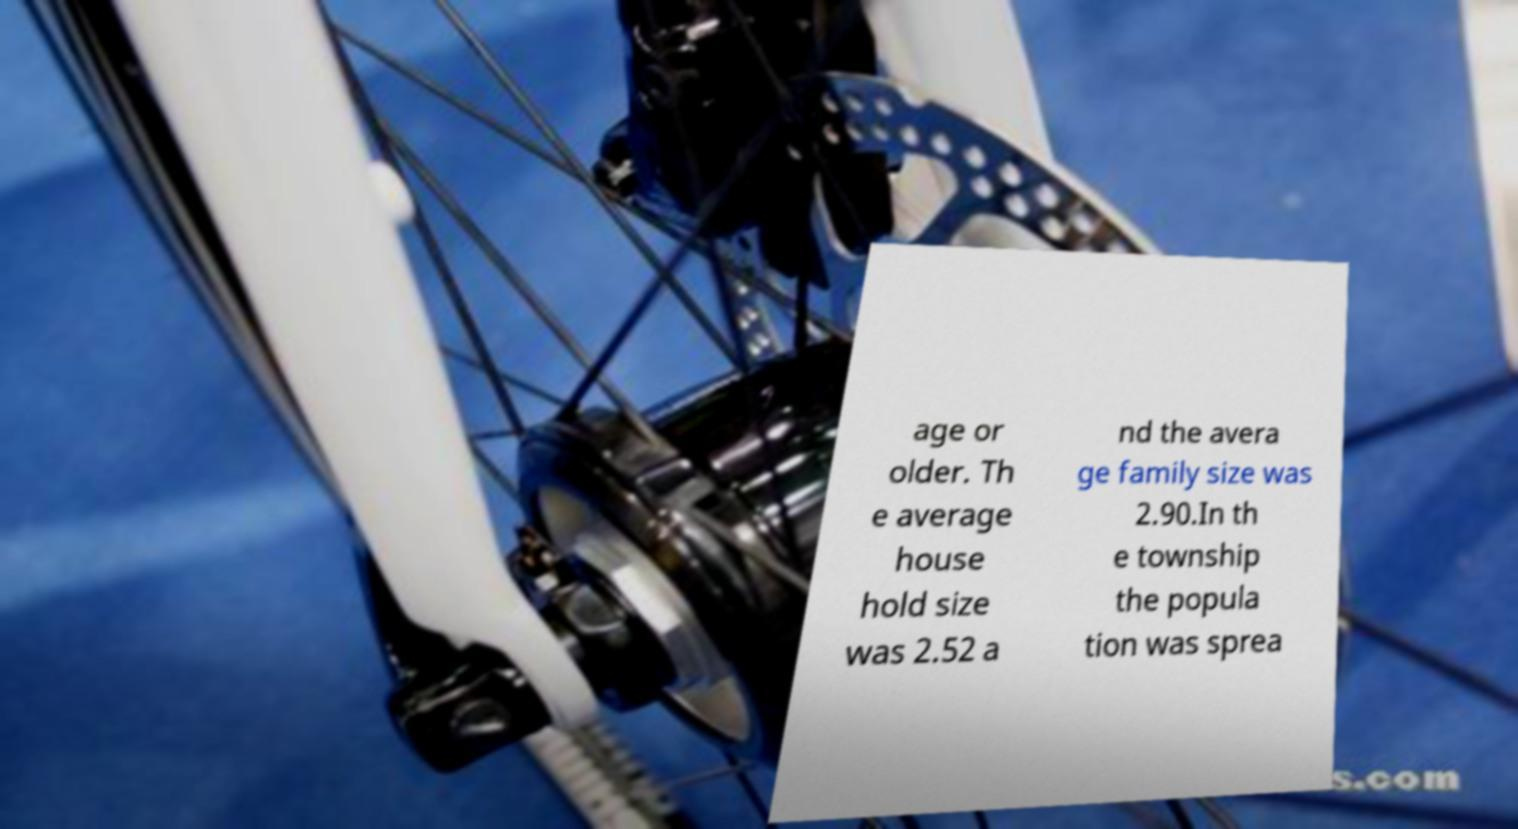Can you accurately transcribe the text from the provided image for me? age or older. Th e average house hold size was 2.52 a nd the avera ge family size was 2.90.In th e township the popula tion was sprea 